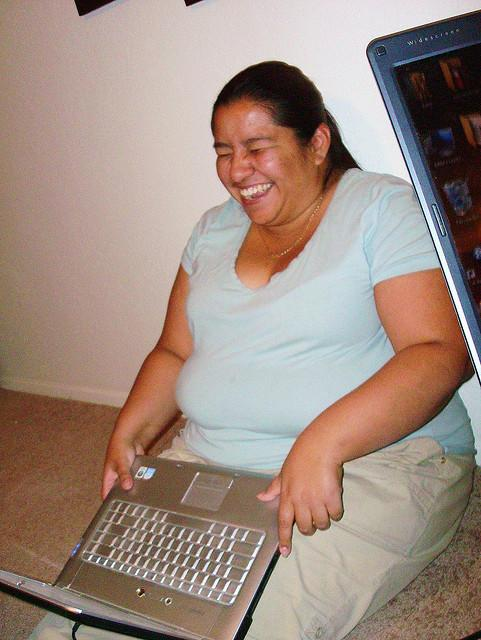What OS is the laptop on the right displaying on its screen?

Choices:
A) windows xp
B) macos
C) windows 10
D) windows vista windows vista 